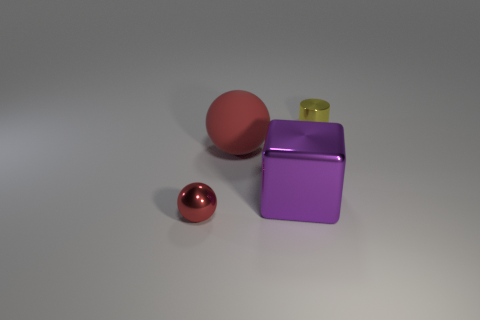What lighting conditions are present in the scene? The lighting in the scene suggests a diffuse, possibly overcast illumination, with soft shadows indicating an indirect light source without harsh highlights. This evenly distributed light accentuates the objects' shapes and textures. How does the lighting affect the appearance of the materials? The lighting conditions serve to emphasize the material properties of the objects. The metallic objects reflect light and show their lustrous quality, while the matte sphere absorbs light and displays a soft, uniform color without glare. 